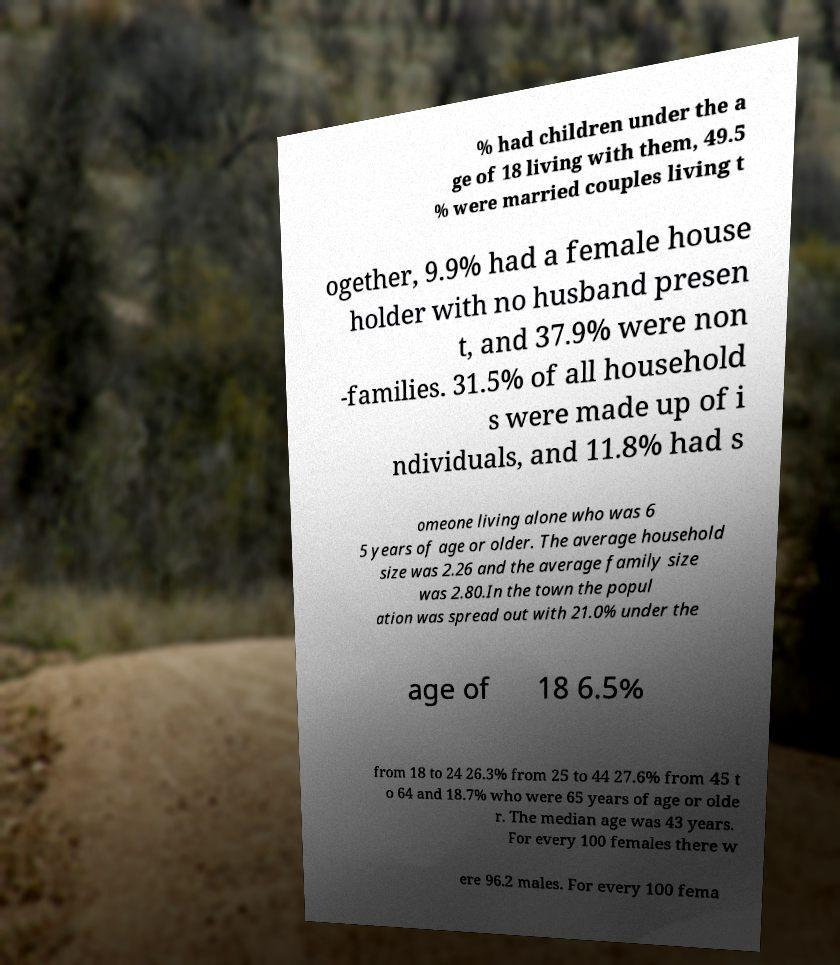Could you extract and type out the text from this image? % had children under the a ge of 18 living with them, 49.5 % were married couples living t ogether, 9.9% had a female house holder with no husband presen t, and 37.9% were non -families. 31.5% of all household s were made up of i ndividuals, and 11.8% had s omeone living alone who was 6 5 years of age or older. The average household size was 2.26 and the average family size was 2.80.In the town the popul ation was spread out with 21.0% under the age of 18 6.5% from 18 to 24 26.3% from 25 to 44 27.6% from 45 t o 64 and 18.7% who were 65 years of age or olde r. The median age was 43 years. For every 100 females there w ere 96.2 males. For every 100 fema 